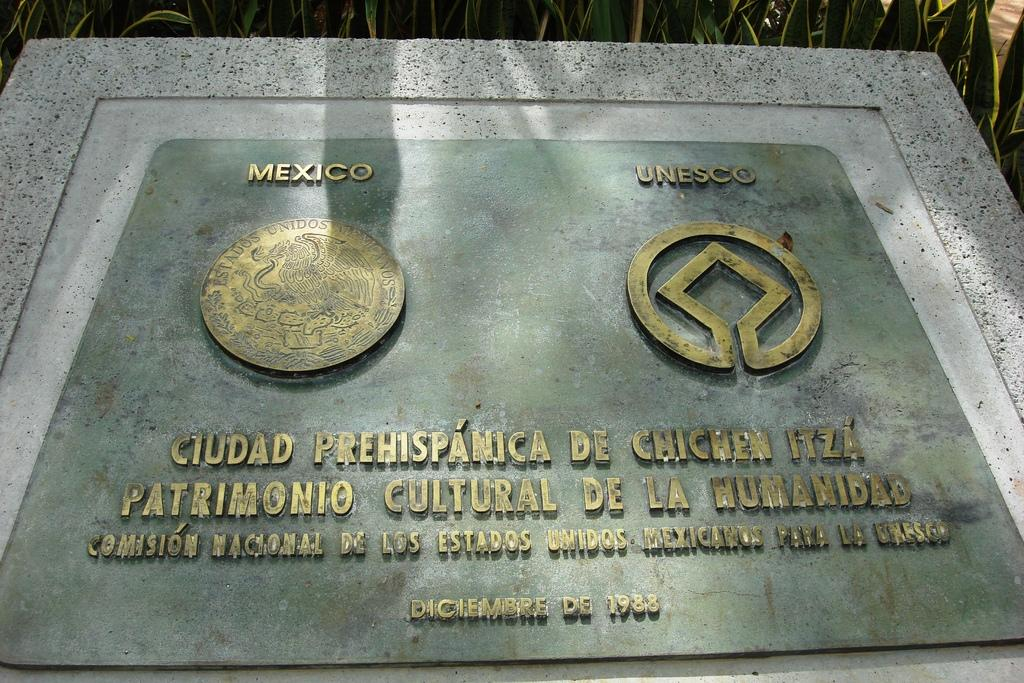<image>
Create a compact narrative representing the image presented. A plaque commemerates a 1983 event involving Mexico and Unesco. 